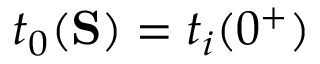Convert formula to latex. <formula><loc_0><loc_0><loc_500><loc_500>t _ { 0 } ( S ) = t _ { i } ( 0 ^ { + } )</formula> 